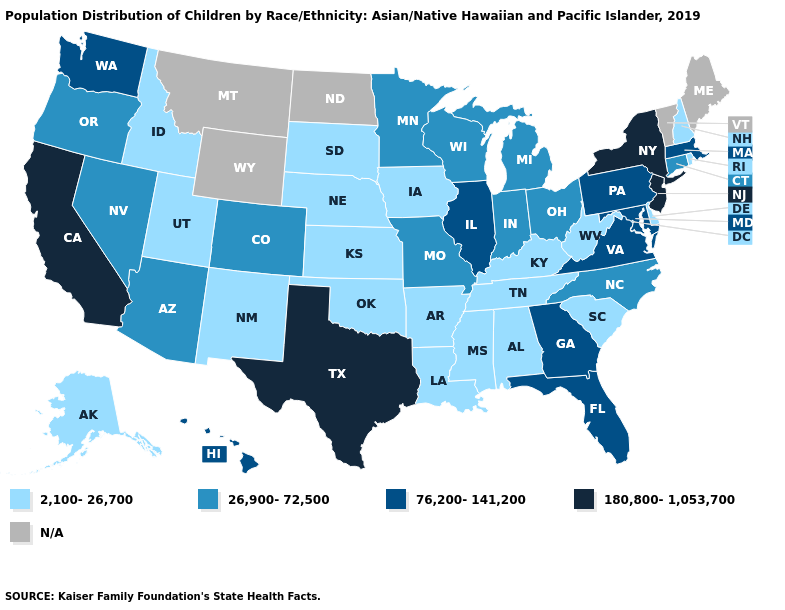Name the states that have a value in the range N/A?
Write a very short answer. Maine, Montana, North Dakota, Vermont, Wyoming. What is the highest value in the Northeast ?
Short answer required. 180,800-1,053,700. Does the first symbol in the legend represent the smallest category?
Give a very brief answer. Yes. Which states have the lowest value in the USA?
Keep it brief. Alabama, Alaska, Arkansas, Delaware, Idaho, Iowa, Kansas, Kentucky, Louisiana, Mississippi, Nebraska, New Hampshire, New Mexico, Oklahoma, Rhode Island, South Carolina, South Dakota, Tennessee, Utah, West Virginia. Does New Jersey have the highest value in the USA?
Concise answer only. Yes. What is the value of West Virginia?
Write a very short answer. 2,100-26,700. Name the states that have a value in the range 26,900-72,500?
Quick response, please. Arizona, Colorado, Connecticut, Indiana, Michigan, Minnesota, Missouri, Nevada, North Carolina, Ohio, Oregon, Wisconsin. Does Pennsylvania have the highest value in the Northeast?
Be succinct. No. What is the value of Idaho?
Write a very short answer. 2,100-26,700. Which states have the lowest value in the USA?
Short answer required. Alabama, Alaska, Arkansas, Delaware, Idaho, Iowa, Kansas, Kentucky, Louisiana, Mississippi, Nebraska, New Hampshire, New Mexico, Oklahoma, Rhode Island, South Carolina, South Dakota, Tennessee, Utah, West Virginia. What is the value of Louisiana?
Concise answer only. 2,100-26,700. Which states have the lowest value in the MidWest?
Short answer required. Iowa, Kansas, Nebraska, South Dakota. Does Maryland have the lowest value in the USA?
Give a very brief answer. No. Among the states that border South Dakota , which have the highest value?
Answer briefly. Minnesota. 